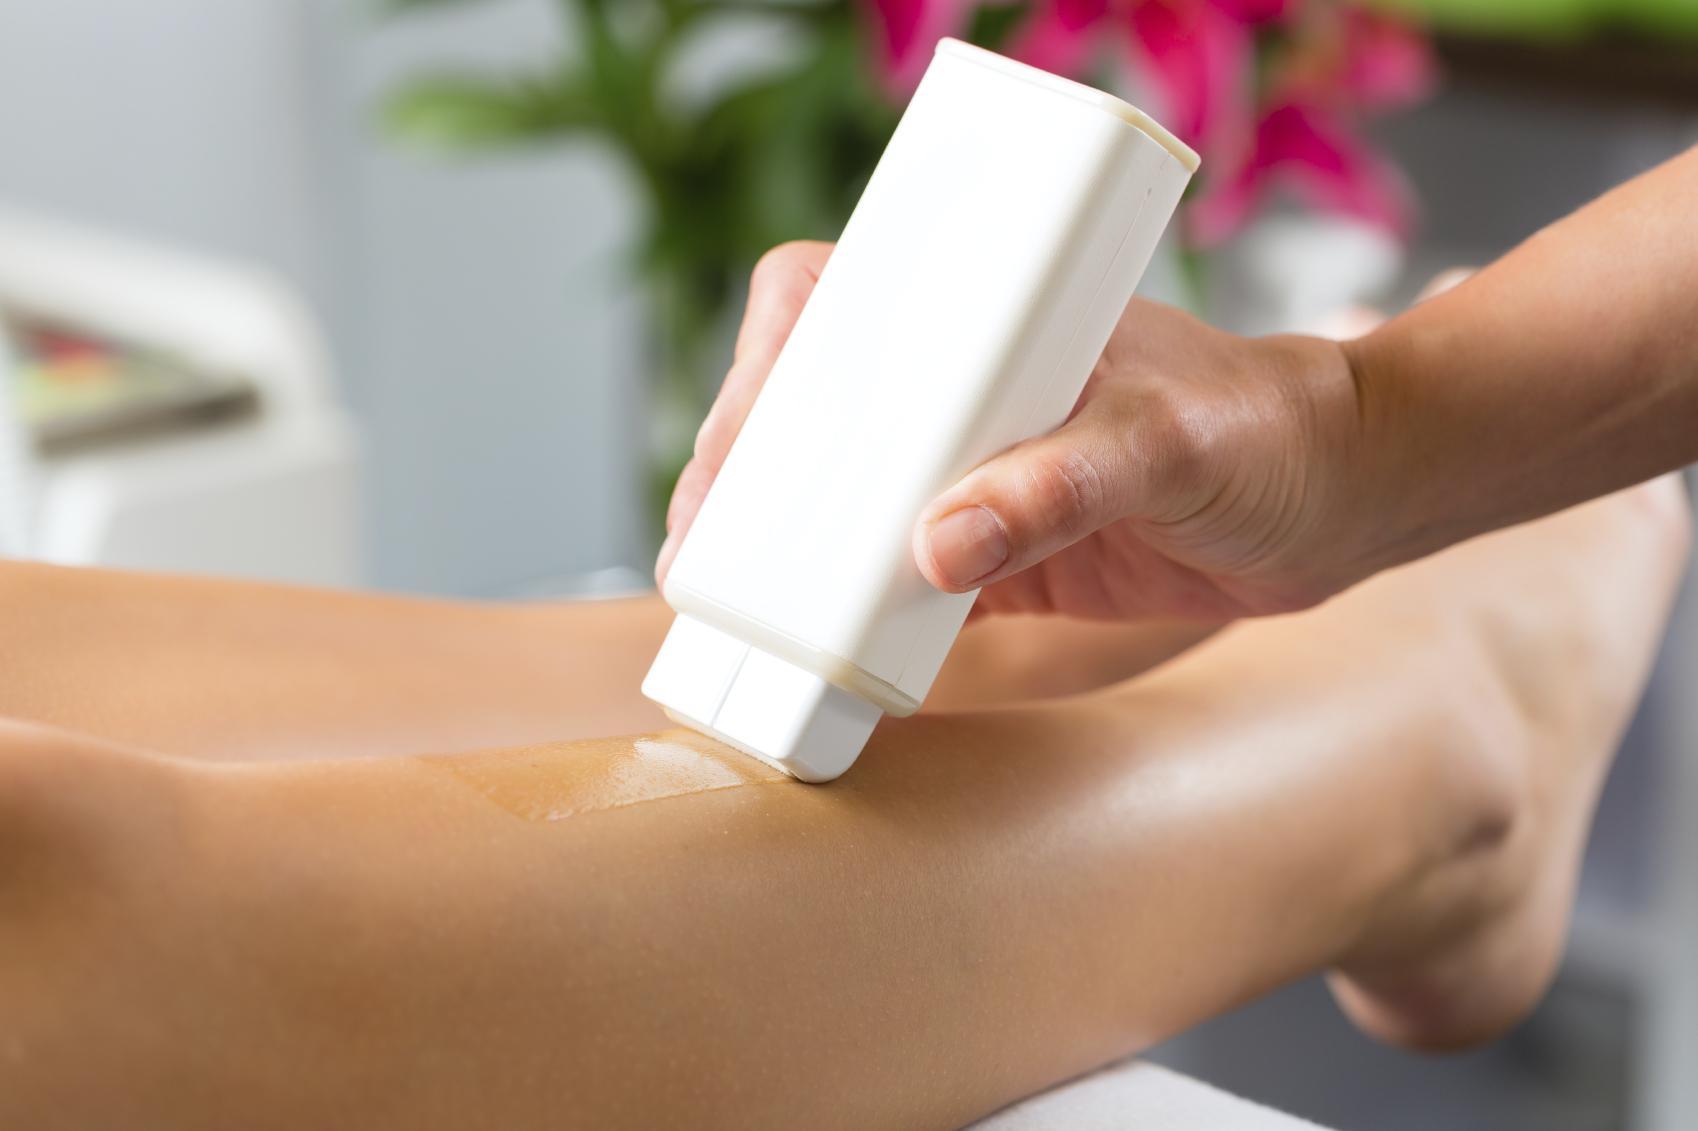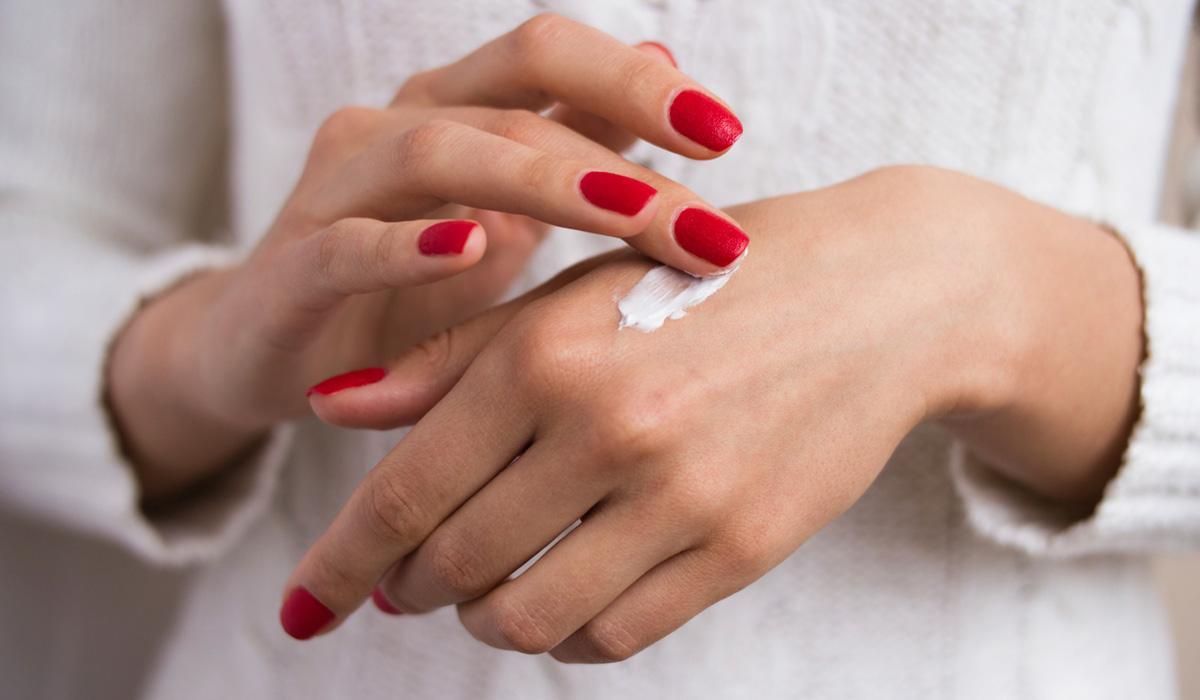The first image is the image on the left, the second image is the image on the right. Considering the images on both sides, is "The images don't show the lotion being applied to anyone's skin." valid? Answer yes or no. No. The first image is the image on the left, the second image is the image on the right. Given the left and right images, does the statement "the left image is a single lotion bottle with a pump top" hold true? Answer yes or no. No. 